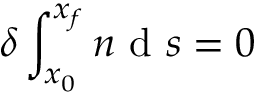Convert formula to latex. <formula><loc_0><loc_0><loc_500><loc_500>\delta \int _ { x _ { 0 } } ^ { x _ { f } } n d s = 0</formula> 